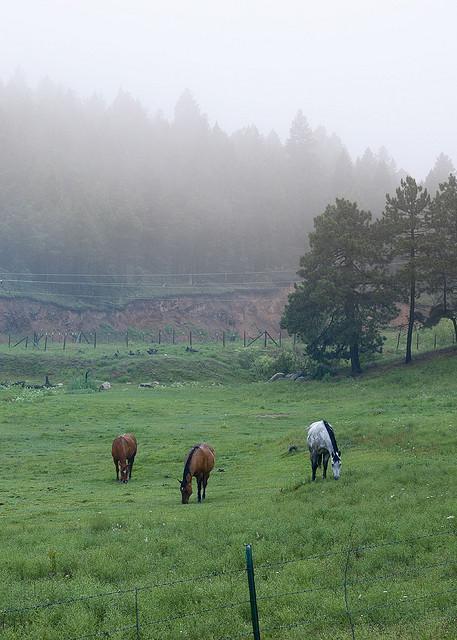How many trees are not in the fog?
Give a very brief answer. 3. How many brown horses are there?
Give a very brief answer. 2. How many animals are there?
Give a very brief answer. 3. How many animals are in the image?
Give a very brief answer. 3. 